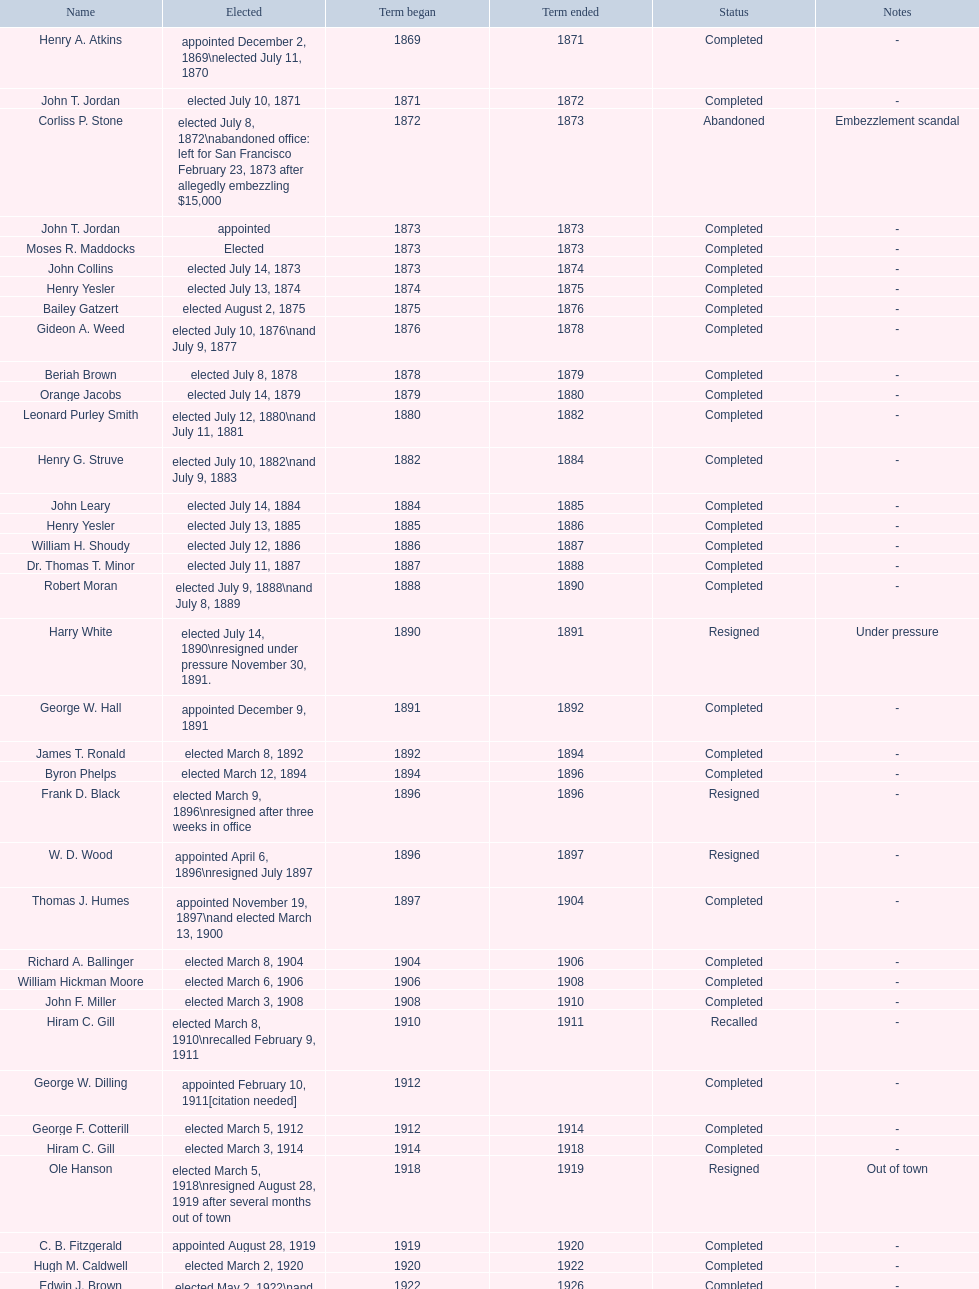In seattle, washington, how many times has a woman been elected as mayor? 1. 